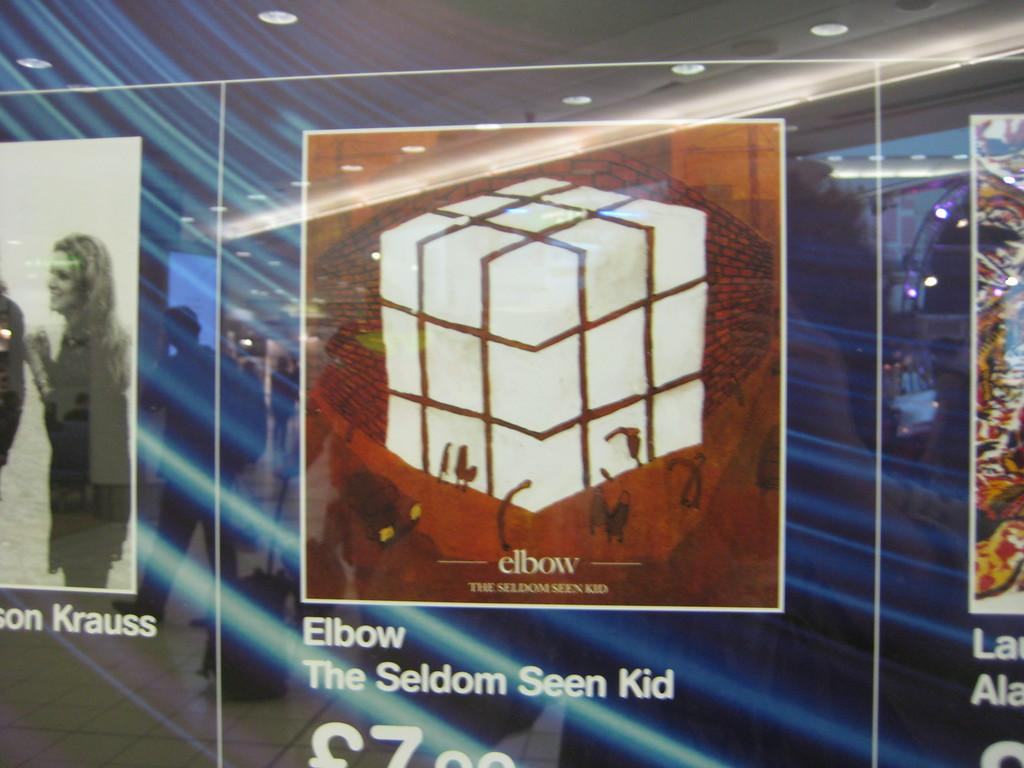<image>
Render a clear and concise summary of the photo. A poster advertises a product called Elbow by the Seldom Seen Kid. 